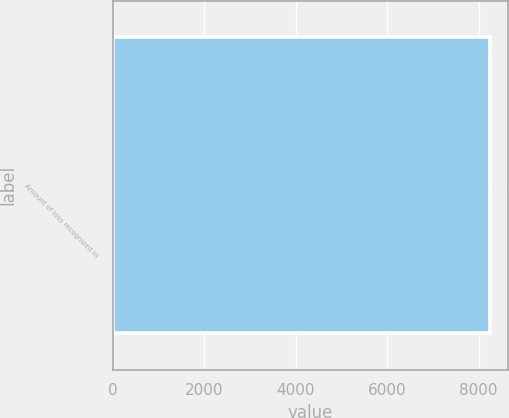Convert chart to OTSL. <chart><loc_0><loc_0><loc_500><loc_500><bar_chart><fcel>Amount of loss recognized in<nl><fcel>8240<nl></chart> 